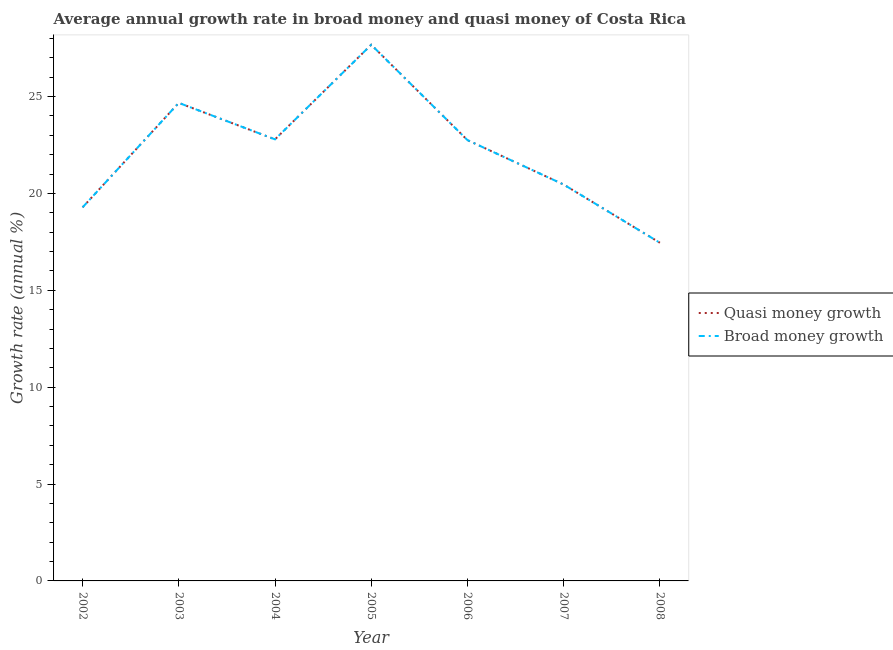What is the annual growth rate in broad money in 2003?
Make the answer very short. 24.68. Across all years, what is the maximum annual growth rate in broad money?
Provide a succinct answer. 27.68. Across all years, what is the minimum annual growth rate in broad money?
Offer a very short reply. 17.46. In which year was the annual growth rate in broad money minimum?
Give a very brief answer. 2008. What is the total annual growth rate in broad money in the graph?
Provide a succinct answer. 155.1. What is the difference between the annual growth rate in quasi money in 2004 and that in 2006?
Keep it short and to the point. 0.04. What is the difference between the annual growth rate in quasi money in 2004 and the annual growth rate in broad money in 2007?
Provide a succinct answer. 2.33. What is the average annual growth rate in quasi money per year?
Ensure brevity in your answer.  22.16. In how many years, is the annual growth rate in broad money greater than 26 %?
Provide a succinct answer. 1. What is the ratio of the annual growth rate in broad money in 2004 to that in 2008?
Give a very brief answer. 1.31. Is the annual growth rate in broad money in 2003 less than that in 2007?
Provide a succinct answer. No. What is the difference between the highest and the second highest annual growth rate in quasi money?
Offer a very short reply. 3. What is the difference between the highest and the lowest annual growth rate in quasi money?
Ensure brevity in your answer.  10.22. In how many years, is the annual growth rate in broad money greater than the average annual growth rate in broad money taken over all years?
Make the answer very short. 4. Is the sum of the annual growth rate in broad money in 2003 and 2007 greater than the maximum annual growth rate in quasi money across all years?
Offer a terse response. Yes. Does the annual growth rate in broad money monotonically increase over the years?
Keep it short and to the point. No. Is the annual growth rate in broad money strictly greater than the annual growth rate in quasi money over the years?
Keep it short and to the point. No. Is the annual growth rate in broad money strictly less than the annual growth rate in quasi money over the years?
Offer a terse response. No. How many lines are there?
Offer a terse response. 2. How many years are there in the graph?
Give a very brief answer. 7. Does the graph contain any zero values?
Offer a terse response. No. Where does the legend appear in the graph?
Offer a very short reply. Center right. How are the legend labels stacked?
Your answer should be very brief. Vertical. What is the title of the graph?
Your answer should be compact. Average annual growth rate in broad money and quasi money of Costa Rica. Does "Imports" appear as one of the legend labels in the graph?
Provide a short and direct response. No. What is the label or title of the Y-axis?
Keep it short and to the point. Growth rate (annual %). What is the Growth rate (annual %) of Quasi money growth in 2002?
Give a very brief answer. 19.28. What is the Growth rate (annual %) of Broad money growth in 2002?
Keep it short and to the point. 19.28. What is the Growth rate (annual %) in Quasi money growth in 2003?
Provide a short and direct response. 24.68. What is the Growth rate (annual %) in Broad money growth in 2003?
Keep it short and to the point. 24.68. What is the Growth rate (annual %) in Quasi money growth in 2004?
Offer a terse response. 22.79. What is the Growth rate (annual %) of Broad money growth in 2004?
Offer a very short reply. 22.79. What is the Growth rate (annual %) in Quasi money growth in 2005?
Make the answer very short. 27.68. What is the Growth rate (annual %) of Broad money growth in 2005?
Your answer should be compact. 27.68. What is the Growth rate (annual %) in Quasi money growth in 2006?
Offer a terse response. 22.76. What is the Growth rate (annual %) of Broad money growth in 2006?
Keep it short and to the point. 22.76. What is the Growth rate (annual %) in Quasi money growth in 2007?
Give a very brief answer. 20.46. What is the Growth rate (annual %) in Broad money growth in 2007?
Your response must be concise. 20.46. What is the Growth rate (annual %) in Quasi money growth in 2008?
Your response must be concise. 17.46. What is the Growth rate (annual %) in Broad money growth in 2008?
Your answer should be compact. 17.46. Across all years, what is the maximum Growth rate (annual %) in Quasi money growth?
Provide a succinct answer. 27.68. Across all years, what is the maximum Growth rate (annual %) in Broad money growth?
Ensure brevity in your answer.  27.68. Across all years, what is the minimum Growth rate (annual %) in Quasi money growth?
Your answer should be compact. 17.46. Across all years, what is the minimum Growth rate (annual %) in Broad money growth?
Make the answer very short. 17.46. What is the total Growth rate (annual %) in Quasi money growth in the graph?
Your response must be concise. 155.1. What is the total Growth rate (annual %) of Broad money growth in the graph?
Your response must be concise. 155.1. What is the difference between the Growth rate (annual %) in Quasi money growth in 2002 and that in 2003?
Your answer should be compact. -5.39. What is the difference between the Growth rate (annual %) of Broad money growth in 2002 and that in 2003?
Provide a short and direct response. -5.39. What is the difference between the Growth rate (annual %) in Quasi money growth in 2002 and that in 2004?
Ensure brevity in your answer.  -3.51. What is the difference between the Growth rate (annual %) of Broad money growth in 2002 and that in 2004?
Ensure brevity in your answer.  -3.51. What is the difference between the Growth rate (annual %) of Quasi money growth in 2002 and that in 2005?
Provide a short and direct response. -8.39. What is the difference between the Growth rate (annual %) of Broad money growth in 2002 and that in 2005?
Provide a short and direct response. -8.39. What is the difference between the Growth rate (annual %) in Quasi money growth in 2002 and that in 2006?
Provide a short and direct response. -3.47. What is the difference between the Growth rate (annual %) in Broad money growth in 2002 and that in 2006?
Give a very brief answer. -3.47. What is the difference between the Growth rate (annual %) in Quasi money growth in 2002 and that in 2007?
Provide a short and direct response. -1.18. What is the difference between the Growth rate (annual %) of Broad money growth in 2002 and that in 2007?
Your response must be concise. -1.18. What is the difference between the Growth rate (annual %) of Quasi money growth in 2002 and that in 2008?
Give a very brief answer. 1.83. What is the difference between the Growth rate (annual %) in Broad money growth in 2002 and that in 2008?
Keep it short and to the point. 1.83. What is the difference between the Growth rate (annual %) of Quasi money growth in 2003 and that in 2004?
Provide a short and direct response. 1.88. What is the difference between the Growth rate (annual %) in Broad money growth in 2003 and that in 2004?
Make the answer very short. 1.88. What is the difference between the Growth rate (annual %) in Quasi money growth in 2003 and that in 2005?
Your answer should be very brief. -3. What is the difference between the Growth rate (annual %) of Broad money growth in 2003 and that in 2005?
Keep it short and to the point. -3. What is the difference between the Growth rate (annual %) of Quasi money growth in 2003 and that in 2006?
Offer a very short reply. 1.92. What is the difference between the Growth rate (annual %) in Broad money growth in 2003 and that in 2006?
Provide a short and direct response. 1.92. What is the difference between the Growth rate (annual %) of Quasi money growth in 2003 and that in 2007?
Offer a terse response. 4.22. What is the difference between the Growth rate (annual %) in Broad money growth in 2003 and that in 2007?
Your response must be concise. 4.22. What is the difference between the Growth rate (annual %) of Quasi money growth in 2003 and that in 2008?
Your response must be concise. 7.22. What is the difference between the Growth rate (annual %) in Broad money growth in 2003 and that in 2008?
Your answer should be compact. 7.22. What is the difference between the Growth rate (annual %) in Quasi money growth in 2004 and that in 2005?
Offer a terse response. -4.88. What is the difference between the Growth rate (annual %) of Broad money growth in 2004 and that in 2005?
Your response must be concise. -4.88. What is the difference between the Growth rate (annual %) in Quasi money growth in 2004 and that in 2006?
Ensure brevity in your answer.  0.04. What is the difference between the Growth rate (annual %) of Broad money growth in 2004 and that in 2006?
Provide a short and direct response. 0.04. What is the difference between the Growth rate (annual %) of Quasi money growth in 2004 and that in 2007?
Your response must be concise. 2.33. What is the difference between the Growth rate (annual %) in Broad money growth in 2004 and that in 2007?
Your answer should be very brief. 2.33. What is the difference between the Growth rate (annual %) in Quasi money growth in 2004 and that in 2008?
Provide a short and direct response. 5.34. What is the difference between the Growth rate (annual %) in Broad money growth in 2004 and that in 2008?
Offer a terse response. 5.34. What is the difference between the Growth rate (annual %) of Quasi money growth in 2005 and that in 2006?
Keep it short and to the point. 4.92. What is the difference between the Growth rate (annual %) in Broad money growth in 2005 and that in 2006?
Your answer should be very brief. 4.92. What is the difference between the Growth rate (annual %) in Quasi money growth in 2005 and that in 2007?
Offer a terse response. 7.21. What is the difference between the Growth rate (annual %) of Broad money growth in 2005 and that in 2007?
Make the answer very short. 7.21. What is the difference between the Growth rate (annual %) of Quasi money growth in 2005 and that in 2008?
Give a very brief answer. 10.22. What is the difference between the Growth rate (annual %) in Broad money growth in 2005 and that in 2008?
Give a very brief answer. 10.22. What is the difference between the Growth rate (annual %) in Quasi money growth in 2006 and that in 2007?
Your answer should be very brief. 2.29. What is the difference between the Growth rate (annual %) in Broad money growth in 2006 and that in 2007?
Keep it short and to the point. 2.29. What is the difference between the Growth rate (annual %) of Quasi money growth in 2006 and that in 2008?
Provide a succinct answer. 5.3. What is the difference between the Growth rate (annual %) in Broad money growth in 2006 and that in 2008?
Give a very brief answer. 5.3. What is the difference between the Growth rate (annual %) in Quasi money growth in 2007 and that in 2008?
Your answer should be compact. 3.01. What is the difference between the Growth rate (annual %) of Broad money growth in 2007 and that in 2008?
Provide a succinct answer. 3.01. What is the difference between the Growth rate (annual %) in Quasi money growth in 2002 and the Growth rate (annual %) in Broad money growth in 2003?
Give a very brief answer. -5.39. What is the difference between the Growth rate (annual %) in Quasi money growth in 2002 and the Growth rate (annual %) in Broad money growth in 2004?
Give a very brief answer. -3.51. What is the difference between the Growth rate (annual %) of Quasi money growth in 2002 and the Growth rate (annual %) of Broad money growth in 2005?
Make the answer very short. -8.39. What is the difference between the Growth rate (annual %) in Quasi money growth in 2002 and the Growth rate (annual %) in Broad money growth in 2006?
Offer a terse response. -3.47. What is the difference between the Growth rate (annual %) in Quasi money growth in 2002 and the Growth rate (annual %) in Broad money growth in 2007?
Your answer should be very brief. -1.18. What is the difference between the Growth rate (annual %) of Quasi money growth in 2002 and the Growth rate (annual %) of Broad money growth in 2008?
Offer a terse response. 1.83. What is the difference between the Growth rate (annual %) of Quasi money growth in 2003 and the Growth rate (annual %) of Broad money growth in 2004?
Offer a terse response. 1.88. What is the difference between the Growth rate (annual %) of Quasi money growth in 2003 and the Growth rate (annual %) of Broad money growth in 2005?
Provide a short and direct response. -3. What is the difference between the Growth rate (annual %) in Quasi money growth in 2003 and the Growth rate (annual %) in Broad money growth in 2006?
Offer a terse response. 1.92. What is the difference between the Growth rate (annual %) in Quasi money growth in 2003 and the Growth rate (annual %) in Broad money growth in 2007?
Provide a short and direct response. 4.22. What is the difference between the Growth rate (annual %) of Quasi money growth in 2003 and the Growth rate (annual %) of Broad money growth in 2008?
Give a very brief answer. 7.22. What is the difference between the Growth rate (annual %) of Quasi money growth in 2004 and the Growth rate (annual %) of Broad money growth in 2005?
Your response must be concise. -4.88. What is the difference between the Growth rate (annual %) in Quasi money growth in 2004 and the Growth rate (annual %) in Broad money growth in 2006?
Make the answer very short. 0.04. What is the difference between the Growth rate (annual %) of Quasi money growth in 2004 and the Growth rate (annual %) of Broad money growth in 2007?
Ensure brevity in your answer.  2.33. What is the difference between the Growth rate (annual %) in Quasi money growth in 2004 and the Growth rate (annual %) in Broad money growth in 2008?
Your answer should be compact. 5.34. What is the difference between the Growth rate (annual %) of Quasi money growth in 2005 and the Growth rate (annual %) of Broad money growth in 2006?
Provide a succinct answer. 4.92. What is the difference between the Growth rate (annual %) in Quasi money growth in 2005 and the Growth rate (annual %) in Broad money growth in 2007?
Give a very brief answer. 7.21. What is the difference between the Growth rate (annual %) of Quasi money growth in 2005 and the Growth rate (annual %) of Broad money growth in 2008?
Your answer should be compact. 10.22. What is the difference between the Growth rate (annual %) in Quasi money growth in 2006 and the Growth rate (annual %) in Broad money growth in 2007?
Your answer should be very brief. 2.29. What is the difference between the Growth rate (annual %) in Quasi money growth in 2006 and the Growth rate (annual %) in Broad money growth in 2008?
Keep it short and to the point. 5.3. What is the difference between the Growth rate (annual %) in Quasi money growth in 2007 and the Growth rate (annual %) in Broad money growth in 2008?
Your response must be concise. 3.01. What is the average Growth rate (annual %) of Quasi money growth per year?
Your answer should be very brief. 22.16. What is the average Growth rate (annual %) in Broad money growth per year?
Give a very brief answer. 22.16. In the year 2003, what is the difference between the Growth rate (annual %) in Quasi money growth and Growth rate (annual %) in Broad money growth?
Your response must be concise. 0. In the year 2007, what is the difference between the Growth rate (annual %) in Quasi money growth and Growth rate (annual %) in Broad money growth?
Your answer should be compact. 0. In the year 2008, what is the difference between the Growth rate (annual %) in Quasi money growth and Growth rate (annual %) in Broad money growth?
Make the answer very short. 0. What is the ratio of the Growth rate (annual %) in Quasi money growth in 2002 to that in 2003?
Your answer should be compact. 0.78. What is the ratio of the Growth rate (annual %) of Broad money growth in 2002 to that in 2003?
Offer a terse response. 0.78. What is the ratio of the Growth rate (annual %) of Quasi money growth in 2002 to that in 2004?
Keep it short and to the point. 0.85. What is the ratio of the Growth rate (annual %) of Broad money growth in 2002 to that in 2004?
Provide a short and direct response. 0.85. What is the ratio of the Growth rate (annual %) in Quasi money growth in 2002 to that in 2005?
Your answer should be compact. 0.7. What is the ratio of the Growth rate (annual %) in Broad money growth in 2002 to that in 2005?
Offer a very short reply. 0.7. What is the ratio of the Growth rate (annual %) of Quasi money growth in 2002 to that in 2006?
Keep it short and to the point. 0.85. What is the ratio of the Growth rate (annual %) of Broad money growth in 2002 to that in 2006?
Ensure brevity in your answer.  0.85. What is the ratio of the Growth rate (annual %) in Quasi money growth in 2002 to that in 2007?
Keep it short and to the point. 0.94. What is the ratio of the Growth rate (annual %) of Broad money growth in 2002 to that in 2007?
Provide a short and direct response. 0.94. What is the ratio of the Growth rate (annual %) of Quasi money growth in 2002 to that in 2008?
Provide a succinct answer. 1.1. What is the ratio of the Growth rate (annual %) in Broad money growth in 2002 to that in 2008?
Make the answer very short. 1.1. What is the ratio of the Growth rate (annual %) in Quasi money growth in 2003 to that in 2004?
Make the answer very short. 1.08. What is the ratio of the Growth rate (annual %) of Broad money growth in 2003 to that in 2004?
Make the answer very short. 1.08. What is the ratio of the Growth rate (annual %) of Quasi money growth in 2003 to that in 2005?
Provide a succinct answer. 0.89. What is the ratio of the Growth rate (annual %) in Broad money growth in 2003 to that in 2005?
Keep it short and to the point. 0.89. What is the ratio of the Growth rate (annual %) of Quasi money growth in 2003 to that in 2006?
Make the answer very short. 1.08. What is the ratio of the Growth rate (annual %) in Broad money growth in 2003 to that in 2006?
Your answer should be compact. 1.08. What is the ratio of the Growth rate (annual %) in Quasi money growth in 2003 to that in 2007?
Ensure brevity in your answer.  1.21. What is the ratio of the Growth rate (annual %) of Broad money growth in 2003 to that in 2007?
Ensure brevity in your answer.  1.21. What is the ratio of the Growth rate (annual %) in Quasi money growth in 2003 to that in 2008?
Give a very brief answer. 1.41. What is the ratio of the Growth rate (annual %) in Broad money growth in 2003 to that in 2008?
Keep it short and to the point. 1.41. What is the ratio of the Growth rate (annual %) of Quasi money growth in 2004 to that in 2005?
Give a very brief answer. 0.82. What is the ratio of the Growth rate (annual %) in Broad money growth in 2004 to that in 2005?
Ensure brevity in your answer.  0.82. What is the ratio of the Growth rate (annual %) in Quasi money growth in 2004 to that in 2007?
Your response must be concise. 1.11. What is the ratio of the Growth rate (annual %) in Broad money growth in 2004 to that in 2007?
Your response must be concise. 1.11. What is the ratio of the Growth rate (annual %) of Quasi money growth in 2004 to that in 2008?
Provide a succinct answer. 1.31. What is the ratio of the Growth rate (annual %) of Broad money growth in 2004 to that in 2008?
Give a very brief answer. 1.31. What is the ratio of the Growth rate (annual %) in Quasi money growth in 2005 to that in 2006?
Give a very brief answer. 1.22. What is the ratio of the Growth rate (annual %) of Broad money growth in 2005 to that in 2006?
Your answer should be very brief. 1.22. What is the ratio of the Growth rate (annual %) in Quasi money growth in 2005 to that in 2007?
Your answer should be very brief. 1.35. What is the ratio of the Growth rate (annual %) of Broad money growth in 2005 to that in 2007?
Keep it short and to the point. 1.35. What is the ratio of the Growth rate (annual %) of Quasi money growth in 2005 to that in 2008?
Provide a short and direct response. 1.59. What is the ratio of the Growth rate (annual %) of Broad money growth in 2005 to that in 2008?
Provide a succinct answer. 1.59. What is the ratio of the Growth rate (annual %) in Quasi money growth in 2006 to that in 2007?
Your response must be concise. 1.11. What is the ratio of the Growth rate (annual %) in Broad money growth in 2006 to that in 2007?
Ensure brevity in your answer.  1.11. What is the ratio of the Growth rate (annual %) in Quasi money growth in 2006 to that in 2008?
Ensure brevity in your answer.  1.3. What is the ratio of the Growth rate (annual %) in Broad money growth in 2006 to that in 2008?
Your response must be concise. 1.3. What is the ratio of the Growth rate (annual %) in Quasi money growth in 2007 to that in 2008?
Ensure brevity in your answer.  1.17. What is the ratio of the Growth rate (annual %) in Broad money growth in 2007 to that in 2008?
Ensure brevity in your answer.  1.17. What is the difference between the highest and the second highest Growth rate (annual %) of Quasi money growth?
Make the answer very short. 3. What is the difference between the highest and the second highest Growth rate (annual %) in Broad money growth?
Provide a succinct answer. 3. What is the difference between the highest and the lowest Growth rate (annual %) of Quasi money growth?
Offer a very short reply. 10.22. What is the difference between the highest and the lowest Growth rate (annual %) in Broad money growth?
Provide a succinct answer. 10.22. 